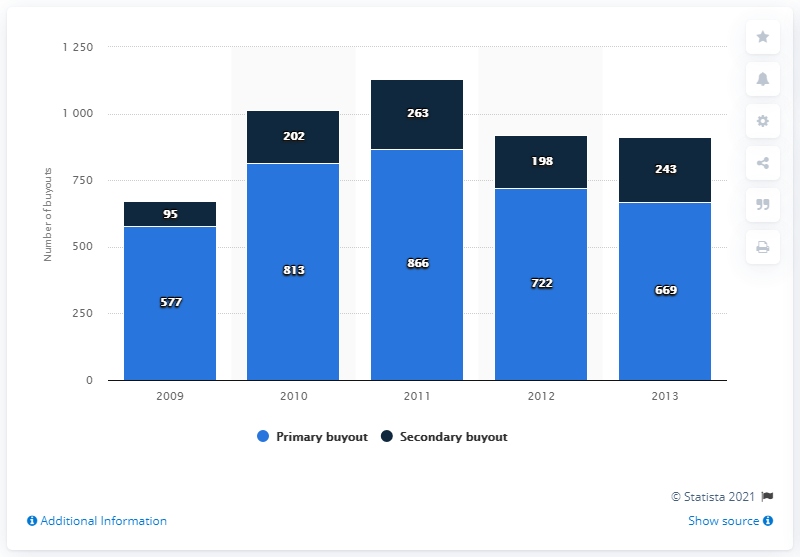Specify some key components in this picture. In 2013, there were 669 deals for primary and secondary buyouts. In 2011, there were 263 deals for secondary buyouts. The data for the secondary buyout in 2011 is 263. There were 866 deals for primary buyouts in 2011. The sum of the secondary buyout in 2012 and 2013 is 441. 